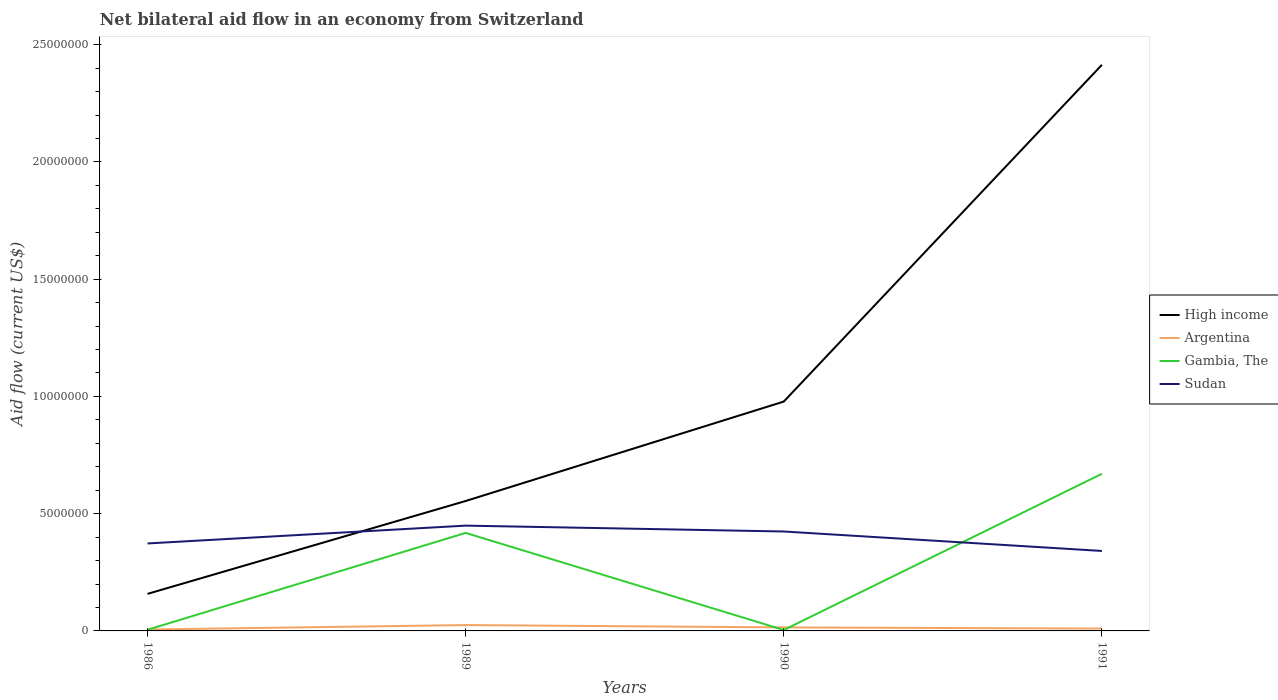What is the total net bilateral aid flow in Gambia, The in the graph?
Ensure brevity in your answer.  -2.52e+06. What is the difference between the highest and the second highest net bilateral aid flow in Sudan?
Ensure brevity in your answer.  1.08e+06. What is the difference between the highest and the lowest net bilateral aid flow in High income?
Your answer should be very brief. 1. Is the net bilateral aid flow in High income strictly greater than the net bilateral aid flow in Gambia, The over the years?
Your answer should be compact. No. How many years are there in the graph?
Provide a succinct answer. 4. What is the difference between two consecutive major ticks on the Y-axis?
Your answer should be compact. 5.00e+06. Are the values on the major ticks of Y-axis written in scientific E-notation?
Give a very brief answer. No. How many legend labels are there?
Make the answer very short. 4. What is the title of the graph?
Give a very brief answer. Net bilateral aid flow in an economy from Switzerland. What is the Aid flow (current US$) in High income in 1986?
Your answer should be very brief. 1.58e+06. What is the Aid flow (current US$) of Argentina in 1986?
Ensure brevity in your answer.  6.00e+04. What is the Aid flow (current US$) of Sudan in 1986?
Provide a succinct answer. 3.73e+06. What is the Aid flow (current US$) of High income in 1989?
Make the answer very short. 5.54e+06. What is the Aid flow (current US$) in Argentina in 1989?
Your response must be concise. 2.50e+05. What is the Aid flow (current US$) of Gambia, The in 1989?
Give a very brief answer. 4.18e+06. What is the Aid flow (current US$) in Sudan in 1989?
Offer a very short reply. 4.49e+06. What is the Aid flow (current US$) of High income in 1990?
Your response must be concise. 9.78e+06. What is the Aid flow (current US$) in Gambia, The in 1990?
Ensure brevity in your answer.  4.00e+04. What is the Aid flow (current US$) of Sudan in 1990?
Offer a terse response. 4.24e+06. What is the Aid flow (current US$) in High income in 1991?
Offer a very short reply. 2.41e+07. What is the Aid flow (current US$) in Argentina in 1991?
Provide a succinct answer. 1.00e+05. What is the Aid flow (current US$) in Gambia, The in 1991?
Your answer should be compact. 6.70e+06. What is the Aid flow (current US$) of Sudan in 1991?
Give a very brief answer. 3.41e+06. Across all years, what is the maximum Aid flow (current US$) of High income?
Provide a succinct answer. 2.41e+07. Across all years, what is the maximum Aid flow (current US$) in Argentina?
Ensure brevity in your answer.  2.50e+05. Across all years, what is the maximum Aid flow (current US$) in Gambia, The?
Ensure brevity in your answer.  6.70e+06. Across all years, what is the maximum Aid flow (current US$) of Sudan?
Ensure brevity in your answer.  4.49e+06. Across all years, what is the minimum Aid flow (current US$) of High income?
Your response must be concise. 1.58e+06. Across all years, what is the minimum Aid flow (current US$) in Argentina?
Make the answer very short. 6.00e+04. Across all years, what is the minimum Aid flow (current US$) of Gambia, The?
Provide a succinct answer. 4.00e+04. Across all years, what is the minimum Aid flow (current US$) of Sudan?
Your response must be concise. 3.41e+06. What is the total Aid flow (current US$) in High income in the graph?
Offer a terse response. 4.10e+07. What is the total Aid flow (current US$) of Argentina in the graph?
Ensure brevity in your answer.  5.60e+05. What is the total Aid flow (current US$) of Gambia, The in the graph?
Your answer should be very brief. 1.10e+07. What is the total Aid flow (current US$) in Sudan in the graph?
Offer a very short reply. 1.59e+07. What is the difference between the Aid flow (current US$) of High income in 1986 and that in 1989?
Your answer should be compact. -3.96e+06. What is the difference between the Aid flow (current US$) in Gambia, The in 1986 and that in 1989?
Your answer should be compact. -4.13e+06. What is the difference between the Aid flow (current US$) in Sudan in 1986 and that in 1989?
Your answer should be very brief. -7.60e+05. What is the difference between the Aid flow (current US$) in High income in 1986 and that in 1990?
Give a very brief answer. -8.20e+06. What is the difference between the Aid flow (current US$) of Argentina in 1986 and that in 1990?
Your response must be concise. -9.00e+04. What is the difference between the Aid flow (current US$) in Gambia, The in 1986 and that in 1990?
Your response must be concise. 10000. What is the difference between the Aid flow (current US$) in Sudan in 1986 and that in 1990?
Provide a succinct answer. -5.10e+05. What is the difference between the Aid flow (current US$) in High income in 1986 and that in 1991?
Your answer should be very brief. -2.26e+07. What is the difference between the Aid flow (current US$) in Argentina in 1986 and that in 1991?
Provide a short and direct response. -4.00e+04. What is the difference between the Aid flow (current US$) of Gambia, The in 1986 and that in 1991?
Your response must be concise. -6.65e+06. What is the difference between the Aid flow (current US$) in High income in 1989 and that in 1990?
Your response must be concise. -4.24e+06. What is the difference between the Aid flow (current US$) in Gambia, The in 1989 and that in 1990?
Your answer should be compact. 4.14e+06. What is the difference between the Aid flow (current US$) of High income in 1989 and that in 1991?
Provide a short and direct response. -1.86e+07. What is the difference between the Aid flow (current US$) of Gambia, The in 1989 and that in 1991?
Ensure brevity in your answer.  -2.52e+06. What is the difference between the Aid flow (current US$) of Sudan in 1989 and that in 1991?
Provide a short and direct response. 1.08e+06. What is the difference between the Aid flow (current US$) in High income in 1990 and that in 1991?
Make the answer very short. -1.44e+07. What is the difference between the Aid flow (current US$) of Gambia, The in 1990 and that in 1991?
Give a very brief answer. -6.66e+06. What is the difference between the Aid flow (current US$) of Sudan in 1990 and that in 1991?
Make the answer very short. 8.30e+05. What is the difference between the Aid flow (current US$) of High income in 1986 and the Aid flow (current US$) of Argentina in 1989?
Offer a very short reply. 1.33e+06. What is the difference between the Aid flow (current US$) of High income in 1986 and the Aid flow (current US$) of Gambia, The in 1989?
Provide a short and direct response. -2.60e+06. What is the difference between the Aid flow (current US$) in High income in 1986 and the Aid flow (current US$) in Sudan in 1989?
Your answer should be very brief. -2.91e+06. What is the difference between the Aid flow (current US$) of Argentina in 1986 and the Aid flow (current US$) of Gambia, The in 1989?
Your answer should be very brief. -4.12e+06. What is the difference between the Aid flow (current US$) of Argentina in 1986 and the Aid flow (current US$) of Sudan in 1989?
Your answer should be compact. -4.43e+06. What is the difference between the Aid flow (current US$) in Gambia, The in 1986 and the Aid flow (current US$) in Sudan in 1989?
Provide a succinct answer. -4.44e+06. What is the difference between the Aid flow (current US$) in High income in 1986 and the Aid flow (current US$) in Argentina in 1990?
Provide a short and direct response. 1.43e+06. What is the difference between the Aid flow (current US$) in High income in 1986 and the Aid flow (current US$) in Gambia, The in 1990?
Your answer should be compact. 1.54e+06. What is the difference between the Aid flow (current US$) of High income in 1986 and the Aid flow (current US$) of Sudan in 1990?
Give a very brief answer. -2.66e+06. What is the difference between the Aid flow (current US$) of Argentina in 1986 and the Aid flow (current US$) of Gambia, The in 1990?
Offer a terse response. 2.00e+04. What is the difference between the Aid flow (current US$) of Argentina in 1986 and the Aid flow (current US$) of Sudan in 1990?
Offer a terse response. -4.18e+06. What is the difference between the Aid flow (current US$) of Gambia, The in 1986 and the Aid flow (current US$) of Sudan in 1990?
Keep it short and to the point. -4.19e+06. What is the difference between the Aid flow (current US$) of High income in 1986 and the Aid flow (current US$) of Argentina in 1991?
Provide a succinct answer. 1.48e+06. What is the difference between the Aid flow (current US$) of High income in 1986 and the Aid flow (current US$) of Gambia, The in 1991?
Your answer should be very brief. -5.12e+06. What is the difference between the Aid flow (current US$) in High income in 1986 and the Aid flow (current US$) in Sudan in 1991?
Give a very brief answer. -1.83e+06. What is the difference between the Aid flow (current US$) in Argentina in 1986 and the Aid flow (current US$) in Gambia, The in 1991?
Your answer should be very brief. -6.64e+06. What is the difference between the Aid flow (current US$) of Argentina in 1986 and the Aid flow (current US$) of Sudan in 1991?
Your response must be concise. -3.35e+06. What is the difference between the Aid flow (current US$) in Gambia, The in 1986 and the Aid flow (current US$) in Sudan in 1991?
Offer a terse response. -3.36e+06. What is the difference between the Aid flow (current US$) in High income in 1989 and the Aid flow (current US$) in Argentina in 1990?
Offer a terse response. 5.39e+06. What is the difference between the Aid flow (current US$) in High income in 1989 and the Aid flow (current US$) in Gambia, The in 1990?
Keep it short and to the point. 5.50e+06. What is the difference between the Aid flow (current US$) in High income in 1989 and the Aid flow (current US$) in Sudan in 1990?
Make the answer very short. 1.30e+06. What is the difference between the Aid flow (current US$) of Argentina in 1989 and the Aid flow (current US$) of Sudan in 1990?
Offer a very short reply. -3.99e+06. What is the difference between the Aid flow (current US$) of High income in 1989 and the Aid flow (current US$) of Argentina in 1991?
Provide a succinct answer. 5.44e+06. What is the difference between the Aid flow (current US$) of High income in 1989 and the Aid flow (current US$) of Gambia, The in 1991?
Make the answer very short. -1.16e+06. What is the difference between the Aid flow (current US$) in High income in 1989 and the Aid flow (current US$) in Sudan in 1991?
Your answer should be compact. 2.13e+06. What is the difference between the Aid flow (current US$) of Argentina in 1989 and the Aid flow (current US$) of Gambia, The in 1991?
Offer a terse response. -6.45e+06. What is the difference between the Aid flow (current US$) in Argentina in 1989 and the Aid flow (current US$) in Sudan in 1991?
Keep it short and to the point. -3.16e+06. What is the difference between the Aid flow (current US$) in Gambia, The in 1989 and the Aid flow (current US$) in Sudan in 1991?
Ensure brevity in your answer.  7.70e+05. What is the difference between the Aid flow (current US$) of High income in 1990 and the Aid flow (current US$) of Argentina in 1991?
Keep it short and to the point. 9.68e+06. What is the difference between the Aid flow (current US$) in High income in 1990 and the Aid flow (current US$) in Gambia, The in 1991?
Give a very brief answer. 3.08e+06. What is the difference between the Aid flow (current US$) in High income in 1990 and the Aid flow (current US$) in Sudan in 1991?
Your answer should be compact. 6.37e+06. What is the difference between the Aid flow (current US$) in Argentina in 1990 and the Aid flow (current US$) in Gambia, The in 1991?
Offer a terse response. -6.55e+06. What is the difference between the Aid flow (current US$) of Argentina in 1990 and the Aid flow (current US$) of Sudan in 1991?
Ensure brevity in your answer.  -3.26e+06. What is the difference between the Aid flow (current US$) in Gambia, The in 1990 and the Aid flow (current US$) in Sudan in 1991?
Your answer should be very brief. -3.37e+06. What is the average Aid flow (current US$) of High income per year?
Provide a succinct answer. 1.03e+07. What is the average Aid flow (current US$) of Argentina per year?
Keep it short and to the point. 1.40e+05. What is the average Aid flow (current US$) in Gambia, The per year?
Your response must be concise. 2.74e+06. What is the average Aid flow (current US$) in Sudan per year?
Provide a succinct answer. 3.97e+06. In the year 1986, what is the difference between the Aid flow (current US$) of High income and Aid flow (current US$) of Argentina?
Offer a terse response. 1.52e+06. In the year 1986, what is the difference between the Aid flow (current US$) of High income and Aid flow (current US$) of Gambia, The?
Offer a very short reply. 1.53e+06. In the year 1986, what is the difference between the Aid flow (current US$) in High income and Aid flow (current US$) in Sudan?
Your response must be concise. -2.15e+06. In the year 1986, what is the difference between the Aid flow (current US$) of Argentina and Aid flow (current US$) of Gambia, The?
Your response must be concise. 10000. In the year 1986, what is the difference between the Aid flow (current US$) in Argentina and Aid flow (current US$) in Sudan?
Keep it short and to the point. -3.67e+06. In the year 1986, what is the difference between the Aid flow (current US$) in Gambia, The and Aid flow (current US$) in Sudan?
Keep it short and to the point. -3.68e+06. In the year 1989, what is the difference between the Aid flow (current US$) in High income and Aid flow (current US$) in Argentina?
Make the answer very short. 5.29e+06. In the year 1989, what is the difference between the Aid flow (current US$) of High income and Aid flow (current US$) of Gambia, The?
Your answer should be compact. 1.36e+06. In the year 1989, what is the difference between the Aid flow (current US$) in High income and Aid flow (current US$) in Sudan?
Give a very brief answer. 1.05e+06. In the year 1989, what is the difference between the Aid flow (current US$) of Argentina and Aid flow (current US$) of Gambia, The?
Your response must be concise. -3.93e+06. In the year 1989, what is the difference between the Aid flow (current US$) of Argentina and Aid flow (current US$) of Sudan?
Give a very brief answer. -4.24e+06. In the year 1989, what is the difference between the Aid flow (current US$) in Gambia, The and Aid flow (current US$) in Sudan?
Provide a short and direct response. -3.10e+05. In the year 1990, what is the difference between the Aid flow (current US$) in High income and Aid flow (current US$) in Argentina?
Offer a terse response. 9.63e+06. In the year 1990, what is the difference between the Aid flow (current US$) of High income and Aid flow (current US$) of Gambia, The?
Your response must be concise. 9.74e+06. In the year 1990, what is the difference between the Aid flow (current US$) in High income and Aid flow (current US$) in Sudan?
Keep it short and to the point. 5.54e+06. In the year 1990, what is the difference between the Aid flow (current US$) of Argentina and Aid flow (current US$) of Sudan?
Offer a terse response. -4.09e+06. In the year 1990, what is the difference between the Aid flow (current US$) of Gambia, The and Aid flow (current US$) of Sudan?
Offer a very short reply. -4.20e+06. In the year 1991, what is the difference between the Aid flow (current US$) of High income and Aid flow (current US$) of Argentina?
Your response must be concise. 2.40e+07. In the year 1991, what is the difference between the Aid flow (current US$) of High income and Aid flow (current US$) of Gambia, The?
Give a very brief answer. 1.74e+07. In the year 1991, what is the difference between the Aid flow (current US$) of High income and Aid flow (current US$) of Sudan?
Provide a short and direct response. 2.07e+07. In the year 1991, what is the difference between the Aid flow (current US$) of Argentina and Aid flow (current US$) of Gambia, The?
Your answer should be compact. -6.60e+06. In the year 1991, what is the difference between the Aid flow (current US$) in Argentina and Aid flow (current US$) in Sudan?
Provide a succinct answer. -3.31e+06. In the year 1991, what is the difference between the Aid flow (current US$) of Gambia, The and Aid flow (current US$) of Sudan?
Give a very brief answer. 3.29e+06. What is the ratio of the Aid flow (current US$) in High income in 1986 to that in 1989?
Your answer should be compact. 0.29. What is the ratio of the Aid flow (current US$) in Argentina in 1986 to that in 1989?
Your response must be concise. 0.24. What is the ratio of the Aid flow (current US$) in Gambia, The in 1986 to that in 1989?
Keep it short and to the point. 0.01. What is the ratio of the Aid flow (current US$) in Sudan in 1986 to that in 1989?
Ensure brevity in your answer.  0.83. What is the ratio of the Aid flow (current US$) in High income in 1986 to that in 1990?
Offer a terse response. 0.16. What is the ratio of the Aid flow (current US$) of Sudan in 1986 to that in 1990?
Your answer should be very brief. 0.88. What is the ratio of the Aid flow (current US$) in High income in 1986 to that in 1991?
Your response must be concise. 0.07. What is the ratio of the Aid flow (current US$) of Argentina in 1986 to that in 1991?
Your response must be concise. 0.6. What is the ratio of the Aid flow (current US$) of Gambia, The in 1986 to that in 1991?
Ensure brevity in your answer.  0.01. What is the ratio of the Aid flow (current US$) of Sudan in 1986 to that in 1991?
Offer a very short reply. 1.09. What is the ratio of the Aid flow (current US$) of High income in 1989 to that in 1990?
Ensure brevity in your answer.  0.57. What is the ratio of the Aid flow (current US$) in Argentina in 1989 to that in 1990?
Your response must be concise. 1.67. What is the ratio of the Aid flow (current US$) in Gambia, The in 1989 to that in 1990?
Offer a terse response. 104.5. What is the ratio of the Aid flow (current US$) of Sudan in 1989 to that in 1990?
Your response must be concise. 1.06. What is the ratio of the Aid flow (current US$) in High income in 1989 to that in 1991?
Make the answer very short. 0.23. What is the ratio of the Aid flow (current US$) of Argentina in 1989 to that in 1991?
Offer a very short reply. 2.5. What is the ratio of the Aid flow (current US$) of Gambia, The in 1989 to that in 1991?
Make the answer very short. 0.62. What is the ratio of the Aid flow (current US$) in Sudan in 1989 to that in 1991?
Provide a succinct answer. 1.32. What is the ratio of the Aid flow (current US$) of High income in 1990 to that in 1991?
Provide a succinct answer. 0.41. What is the ratio of the Aid flow (current US$) of Gambia, The in 1990 to that in 1991?
Keep it short and to the point. 0.01. What is the ratio of the Aid flow (current US$) in Sudan in 1990 to that in 1991?
Provide a short and direct response. 1.24. What is the difference between the highest and the second highest Aid flow (current US$) in High income?
Ensure brevity in your answer.  1.44e+07. What is the difference between the highest and the second highest Aid flow (current US$) in Argentina?
Offer a very short reply. 1.00e+05. What is the difference between the highest and the second highest Aid flow (current US$) in Gambia, The?
Offer a terse response. 2.52e+06. What is the difference between the highest and the lowest Aid flow (current US$) in High income?
Ensure brevity in your answer.  2.26e+07. What is the difference between the highest and the lowest Aid flow (current US$) in Gambia, The?
Keep it short and to the point. 6.66e+06. What is the difference between the highest and the lowest Aid flow (current US$) in Sudan?
Your answer should be very brief. 1.08e+06. 